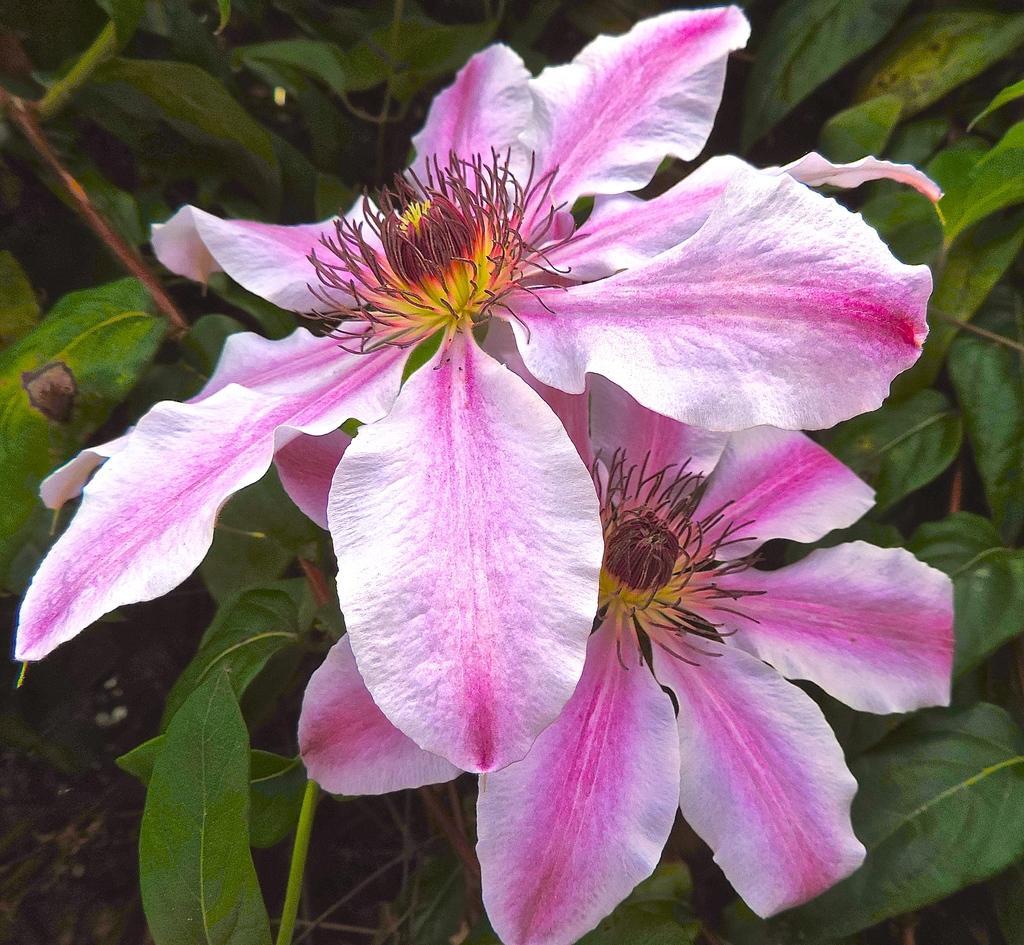Can you describe this image briefly? In this image I can see colorful flowers and plants. 